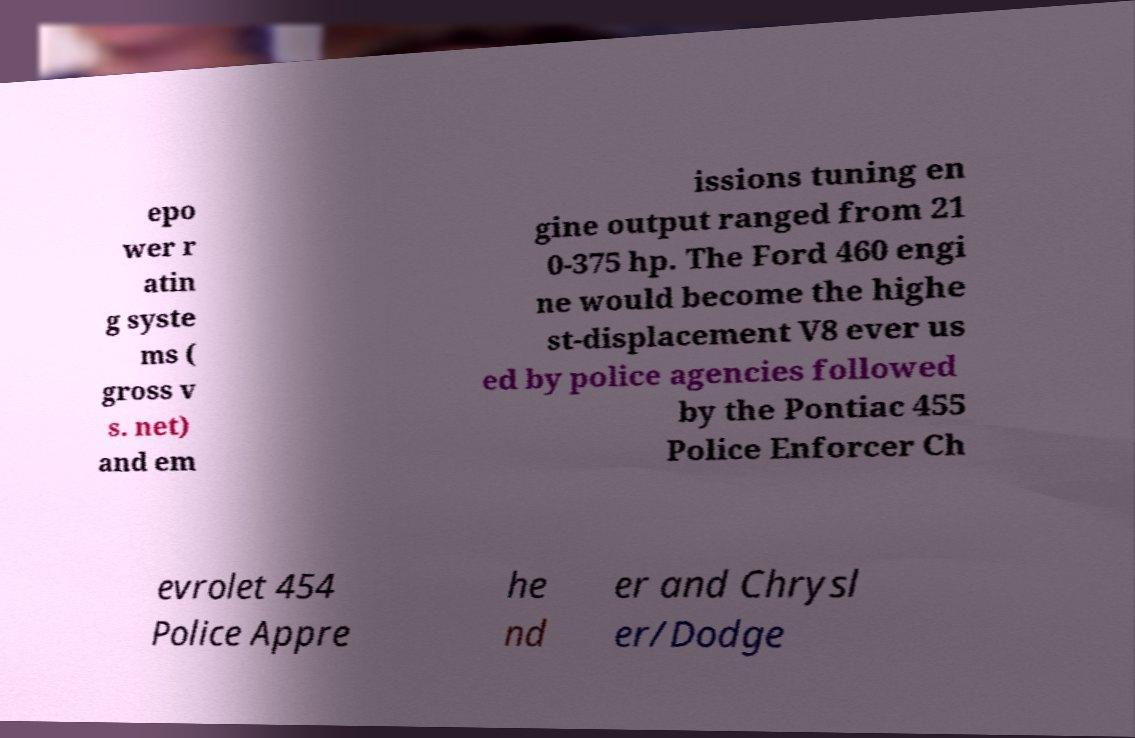Can you read and provide the text displayed in the image?This photo seems to have some interesting text. Can you extract and type it out for me? epo wer r atin g syste ms ( gross v s. net) and em issions tuning en gine output ranged from 21 0-375 hp. The Ford 460 engi ne would become the highe st-displacement V8 ever us ed by police agencies followed by the Pontiac 455 Police Enforcer Ch evrolet 454 Police Appre he nd er and Chrysl er/Dodge 